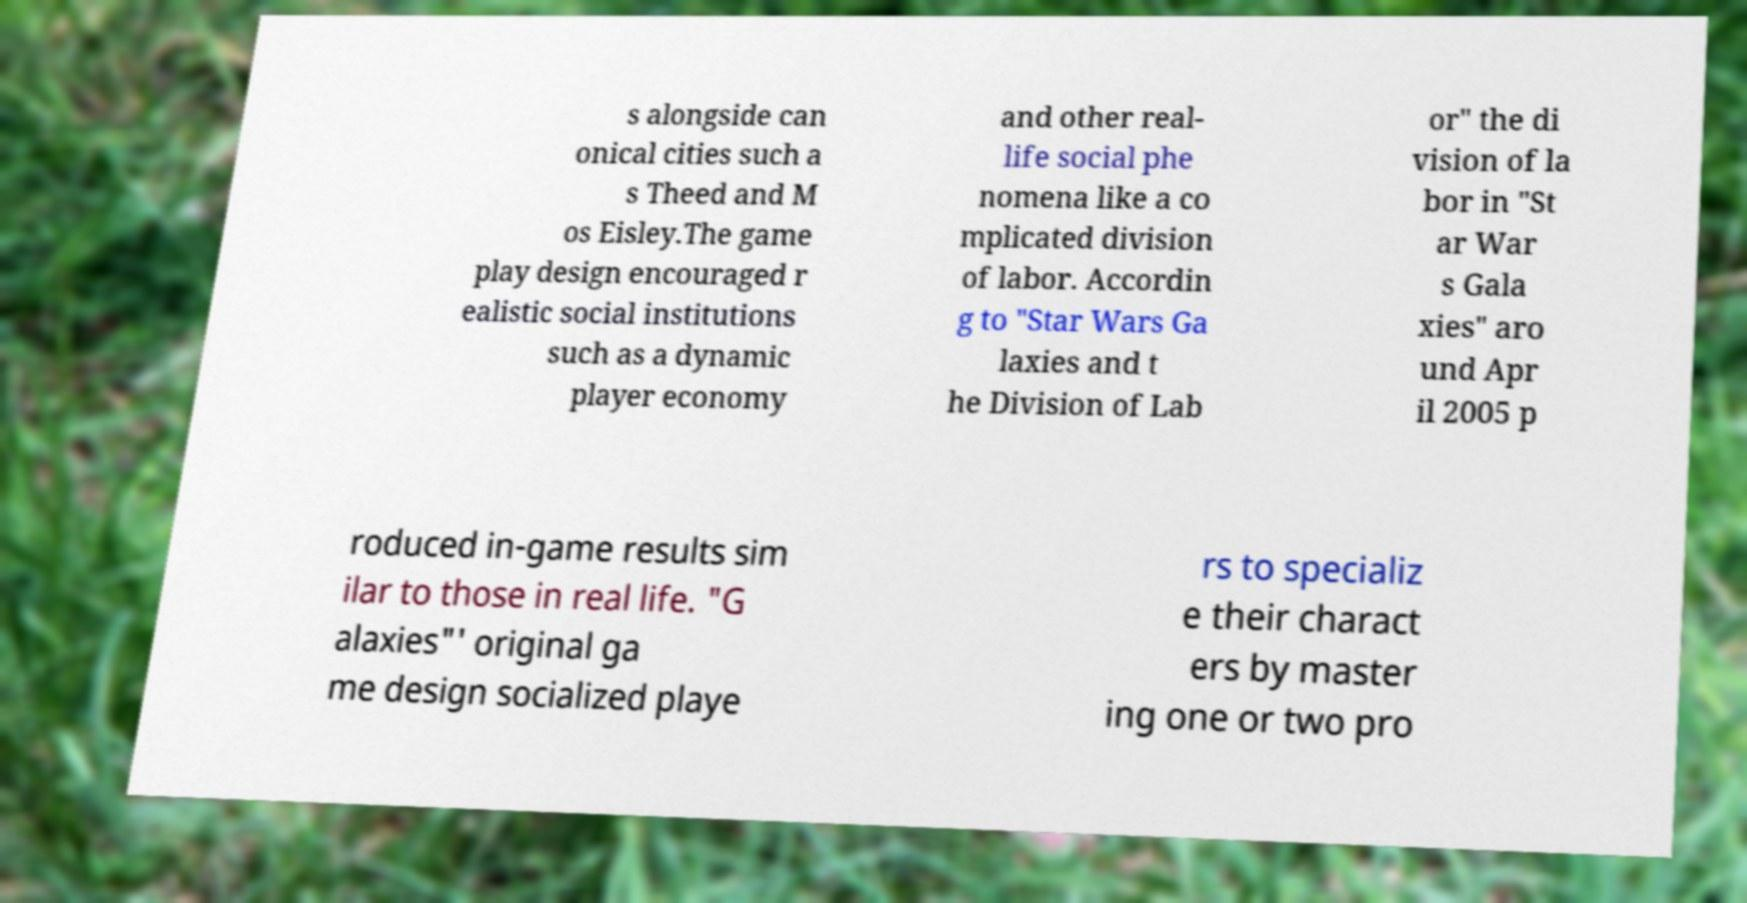Please read and relay the text visible in this image. What does it say? s alongside can onical cities such a s Theed and M os Eisley.The game play design encouraged r ealistic social institutions such as a dynamic player economy and other real- life social phe nomena like a co mplicated division of labor. Accordin g to "Star Wars Ga laxies and t he Division of Lab or" the di vision of la bor in "St ar War s Gala xies" aro und Apr il 2005 p roduced in-game results sim ilar to those in real life. "G alaxies"' original ga me design socialized playe rs to specializ e their charact ers by master ing one or two pro 